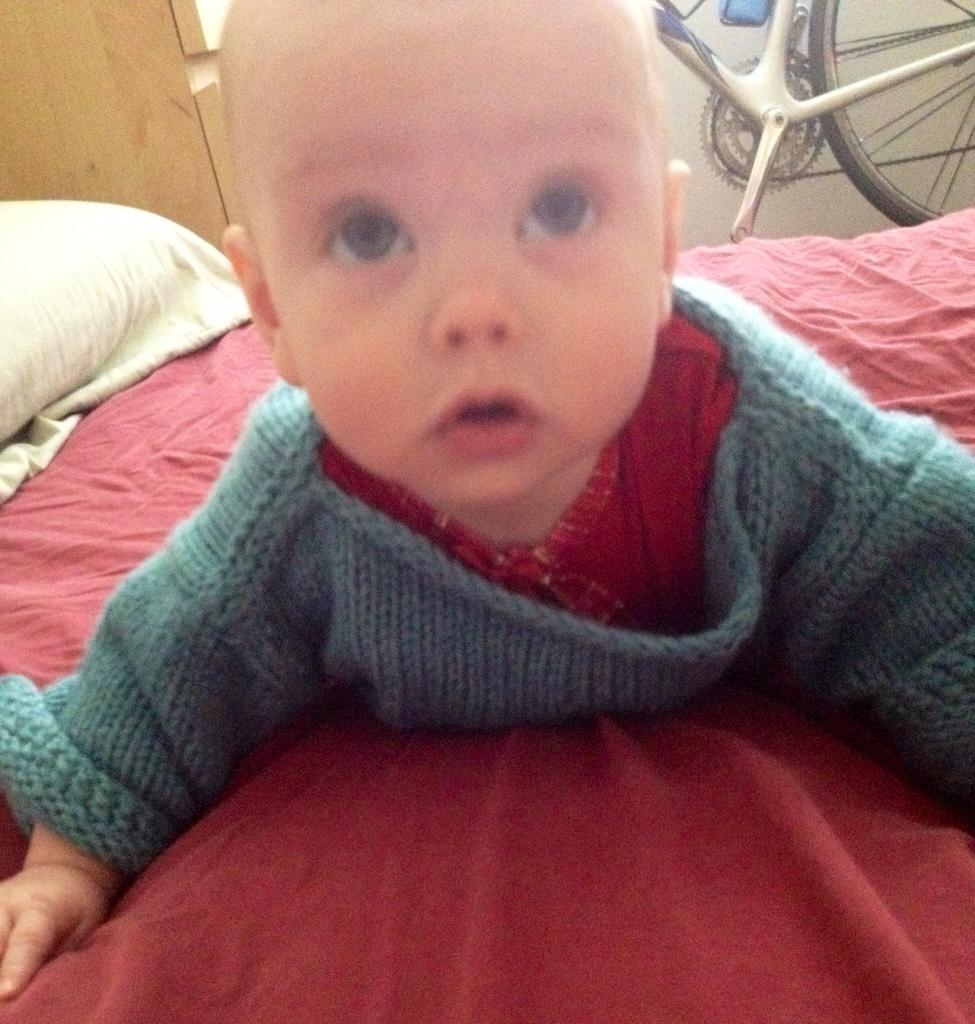What is the main subject of the image? There is a baby in the image. Where is the baby located? The baby is lying on the bed. What is the baby wearing? The baby is wearing clothes. What other items can be seen in the image? There is a bad, a pillow, and a bicycle in the image. What country is the baby visiting on vacation in the image? There is no information about the baby visiting a country or going on vacation in the image. Additionally, the image does not show any furniture like a sofa. 